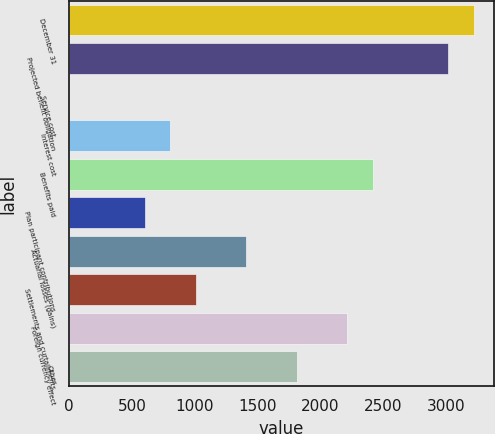<chart> <loc_0><loc_0><loc_500><loc_500><bar_chart><fcel>December 31<fcel>Projected benefit obligation<fcel>Service cost<fcel>Interest cost<fcel>Benefits paid<fcel>Plan participant contributions<fcel>Actuarial losses (gains)<fcel>Settlements and curtailments<fcel>Foreign currency effect<fcel>Other<nl><fcel>3219.08<fcel>3017.9<fcel>0.2<fcel>804.92<fcel>2414.36<fcel>603.74<fcel>1408.46<fcel>1006.1<fcel>2213.18<fcel>1810.82<nl></chart> 